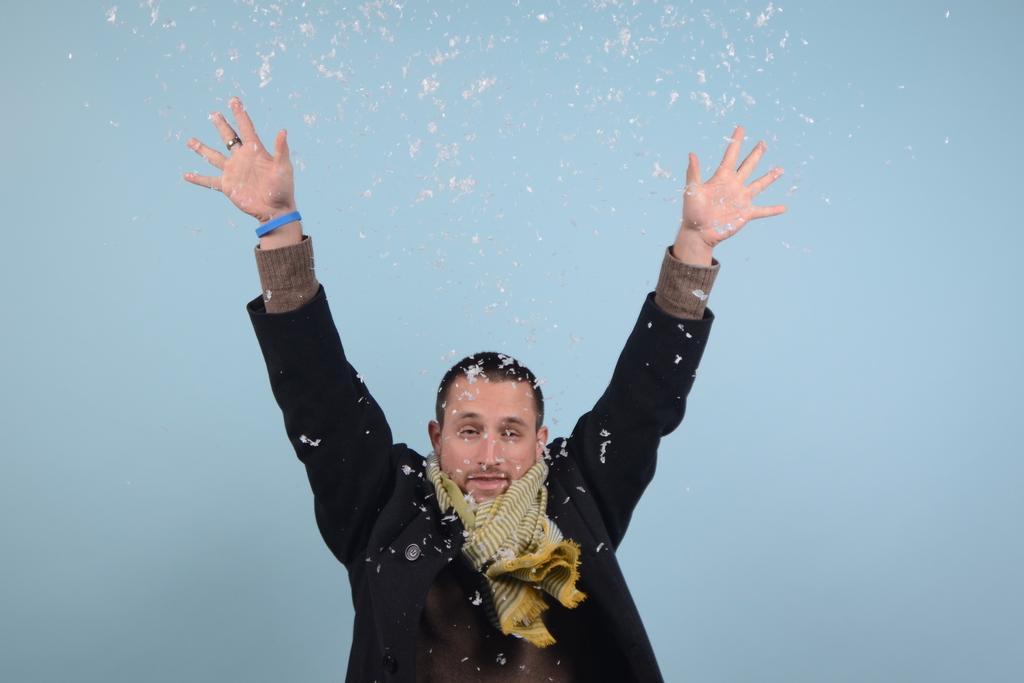Can you describe this image briefly? In this image there is a man in the middle who is raising his hand. He is wearing the black coat and a scarf. At the top of him there are feathers. 